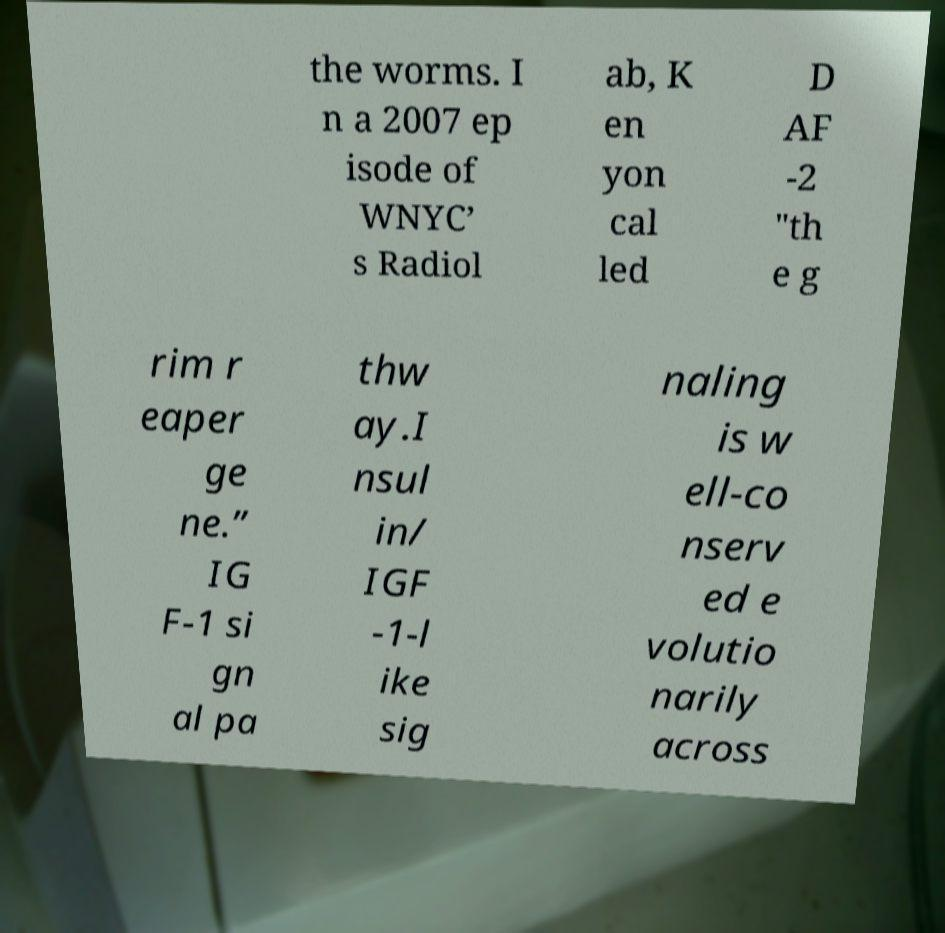Can you accurately transcribe the text from the provided image for me? the worms. I n a 2007 ep isode of WNYC’ s Radiol ab, K en yon cal led D AF -2 "th e g rim r eaper ge ne.” IG F-1 si gn al pa thw ay.I nsul in/ IGF -1-l ike sig naling is w ell-co nserv ed e volutio narily across 